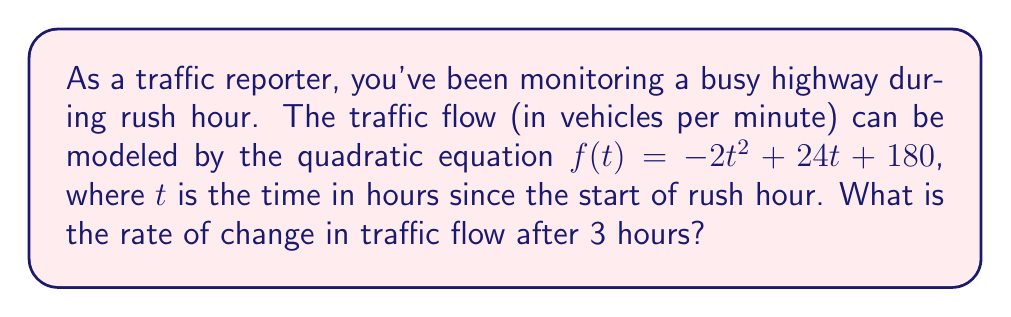What is the answer to this math problem? To solve this problem, we need to find the derivative of the given quadratic function and then evaluate it at $t = 3$. Here's the step-by-step process:

1) The given quadratic function is:
   $$f(t) = -2t^2 + 24t + 180$$

2) To find the rate of change, we need to calculate the derivative of $f(t)$. The derivative of a quadratic function $at^2 + bt + c$ is $2at + b$. So:
   $$f'(t) = -4t + 24$$

3) This derivative function $f'(t)$ represents the instantaneous rate of change of traffic flow at any given time $t$.

4) We need to find the rate of change after 3 hours, so we evaluate $f'(3)$:
   $$f'(3) = -4(3) + 24$$
   $$f'(3) = -12 + 24 = 12$$

5) Therefore, the rate of change in traffic flow after 3 hours is 12 vehicles per minute per hour.

Note: The negative sign in the result would indicate that the traffic flow is decreasing at that rate.
Answer: 12 vehicles per minute per hour 